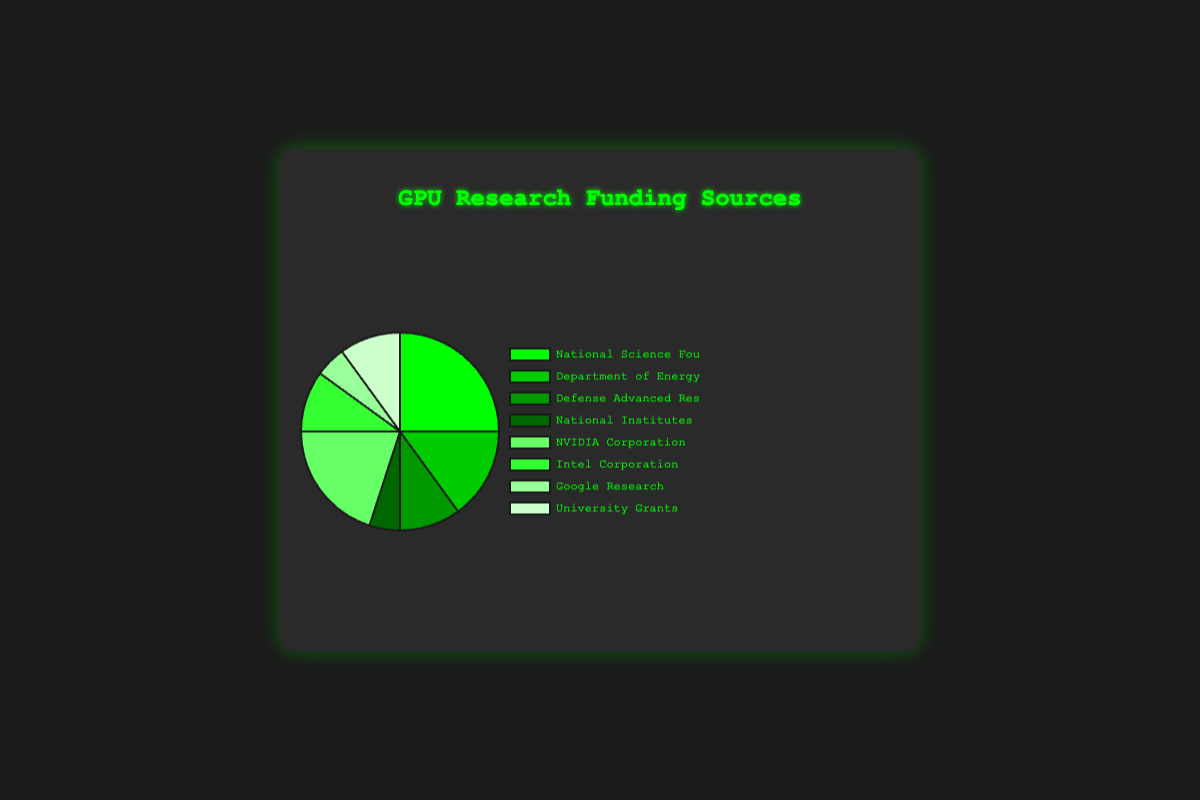What is the total proportion of funding provided by industry (NVIDIA Corporation, Intel Corporation, Google Research)? Summing the proportions: NVIDIA Corporation (20) + Intel Corporation (10) + Google Research (5) = 35
Answer: 35 Which funding source provides the highest proportion? The National Science Foundation has the highest proportion at 25%.
Answer: National Science Foundation What is the difference in funding proportion between the National Science Foundation and the Department of Energy? The National Science Foundation provides 25% and the Department of Energy provides 15%; the difference is 25 - 15 = 10
Answer: 10 What is the combined proportion of funding provided by government agencies (NSF, DOE, DARPA, NIH)? Summing the proportions: NSF (25) + DOE (15) + DARPA (10) + NIH (5) = 55
Answer: 55 Which funding sources have equal proportions of 10%? The Department of Energy, Defense Advanced Research Projects Agency, Intel Corporation, and University Grants each have a proportion of 10%.
Answer: Department of Energy, Defense Advanced Research Projects Agency, Intel Corporation, University Grants How does the proportion of funding from NVIDIA Corporation compare to that of Intel Corporation? NVIDIA Corporation provides 20% while Intel Corporation provides 10%, which means NVIDIA Corporation provides double the proportion of Intel Corporation.
Answer: NVIDIA Corporation provides double What percentage of the total funding is provided by non-governmental sources (NVIDIA Corporation, Intel Corporation, Google Research, University Grants)? Summing the proportions: NVIDIA Corporation (20) + Intel Corporation (10) + Google Research (5) + University Grants (10) = 45
Answer: 45 